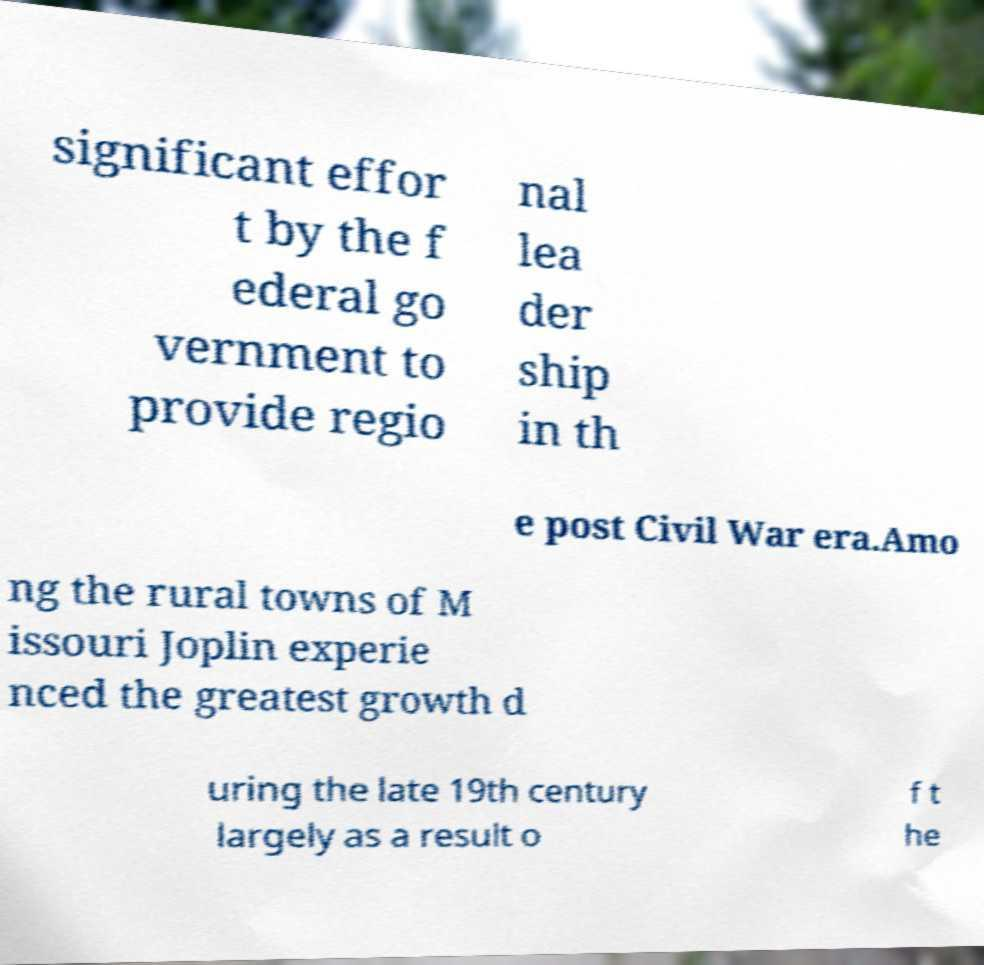What messages or text are displayed in this image? I need them in a readable, typed format. significant effor t by the f ederal go vernment to provide regio nal lea der ship in th e post Civil War era.Amo ng the rural towns of M issouri Joplin experie nced the greatest growth d uring the late 19th century largely as a result o f t he 